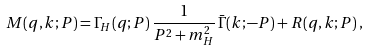<formula> <loc_0><loc_0><loc_500><loc_500>M ( q , k ; P ) = \Gamma _ { H } ( q ; P ) \, \frac { 1 } { P ^ { 2 } + m _ { H } ^ { 2 } } \, \bar { \Gamma } ( k ; - P ) + R ( q , k ; P ) \, ,</formula> 